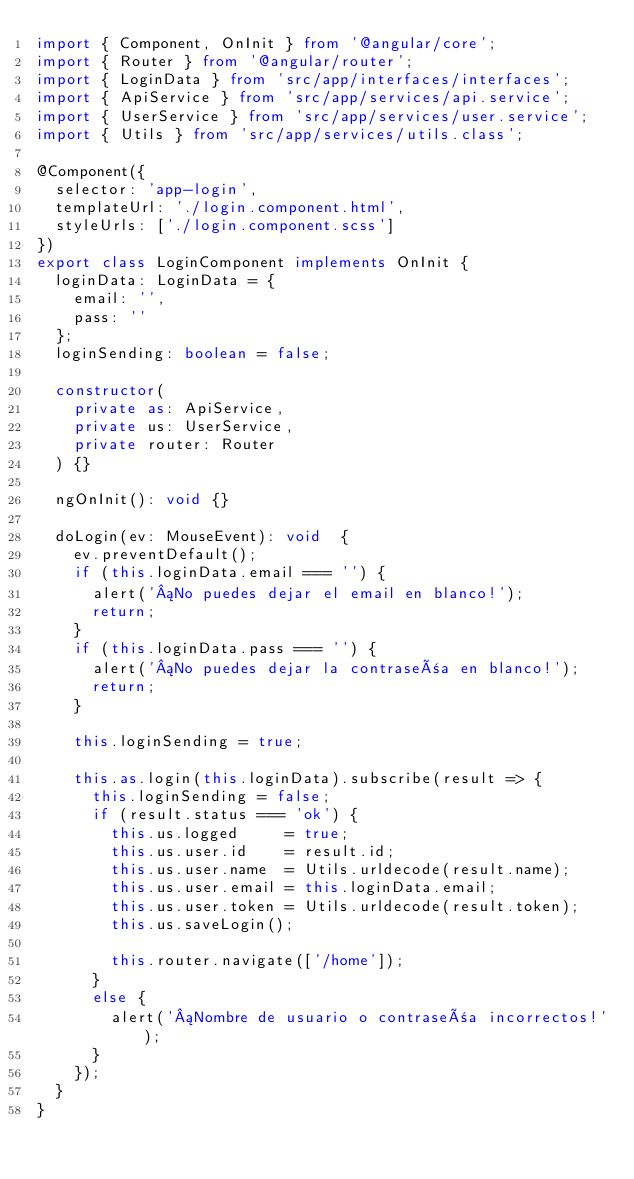<code> <loc_0><loc_0><loc_500><loc_500><_TypeScript_>import { Component, OnInit } from '@angular/core';
import { Router } from '@angular/router';
import { LoginData } from 'src/app/interfaces/interfaces';
import { ApiService } from 'src/app/services/api.service';
import { UserService } from 'src/app/services/user.service';
import { Utils } from 'src/app/services/utils.class';

@Component({
	selector: 'app-login',
	templateUrl: './login.component.html',
	styleUrls: ['./login.component.scss']
})
export class LoginComponent implements OnInit {
	loginData: LoginData = {
		email: '',
		pass: ''
	};
	loginSending: boolean = false;

	constructor(
		private as: ApiService,
		private us: UserService,
		private router: Router
	) {}

	ngOnInit(): void {}

	doLogin(ev: MouseEvent): void  {
		ev.preventDefault();
		if (this.loginData.email === '') {
			alert('¡No puedes dejar el email en blanco!');
			return;
		}
		if (this.loginData.pass === '') {
			alert('¡No puedes dejar la contraseña en blanco!');
			return;
		}

		this.loginSending = true;

		this.as.login(this.loginData).subscribe(result => {
			this.loginSending = false;
			if (result.status === 'ok') {
				this.us.logged     = true;
				this.us.user.id    = result.id;
				this.us.user.name  = Utils.urldecode(result.name);
				this.us.user.email = this.loginData.email;
				this.us.user.token = Utils.urldecode(result.token);
				this.us.saveLogin();

				this.router.navigate(['/home']);
			}
			else {
				alert('¡Nombre de usuario o contraseña incorrectos!');
			}
		});
	}
}
</code> 